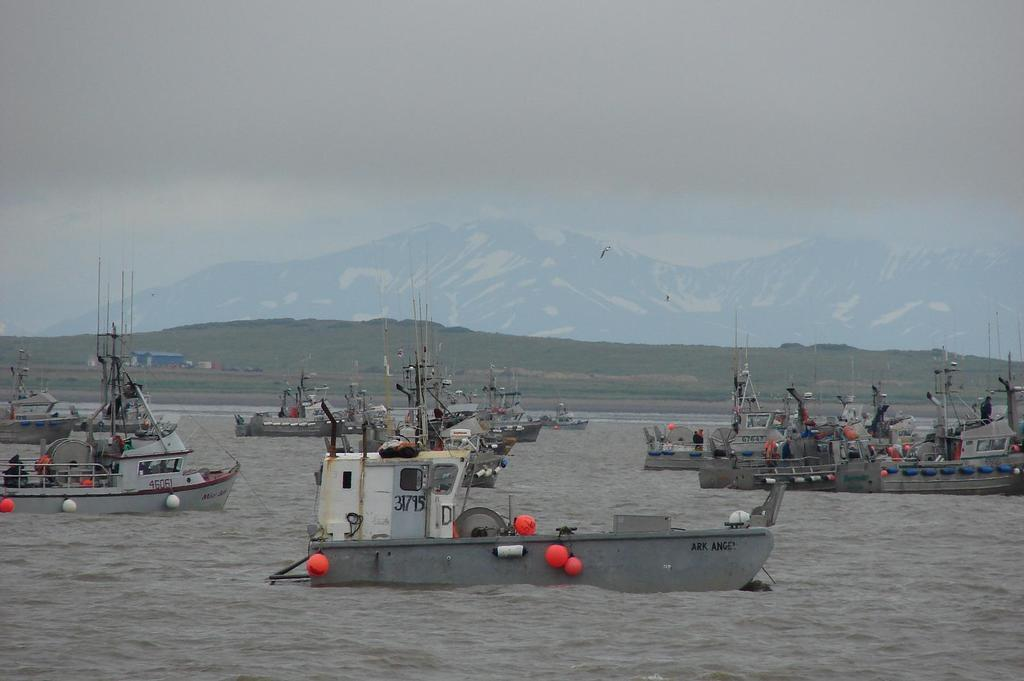What is happening in the water in the image? There are boats sailing on the water in the image. What can be seen in the distance behind the boats? There are mountains visible in the backdrop of the image. How would you describe the sky in the image? The sky is cloudy in the image. Where is the heart-shaped mitten in the image? There is no heart-shaped mitten present in the image. What type of agreement is being made between the boats in the image? There is no indication of any agreement being made between the boats in the image. 